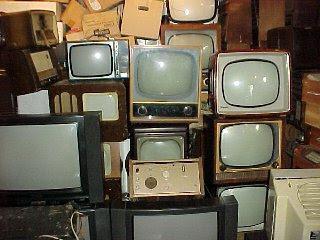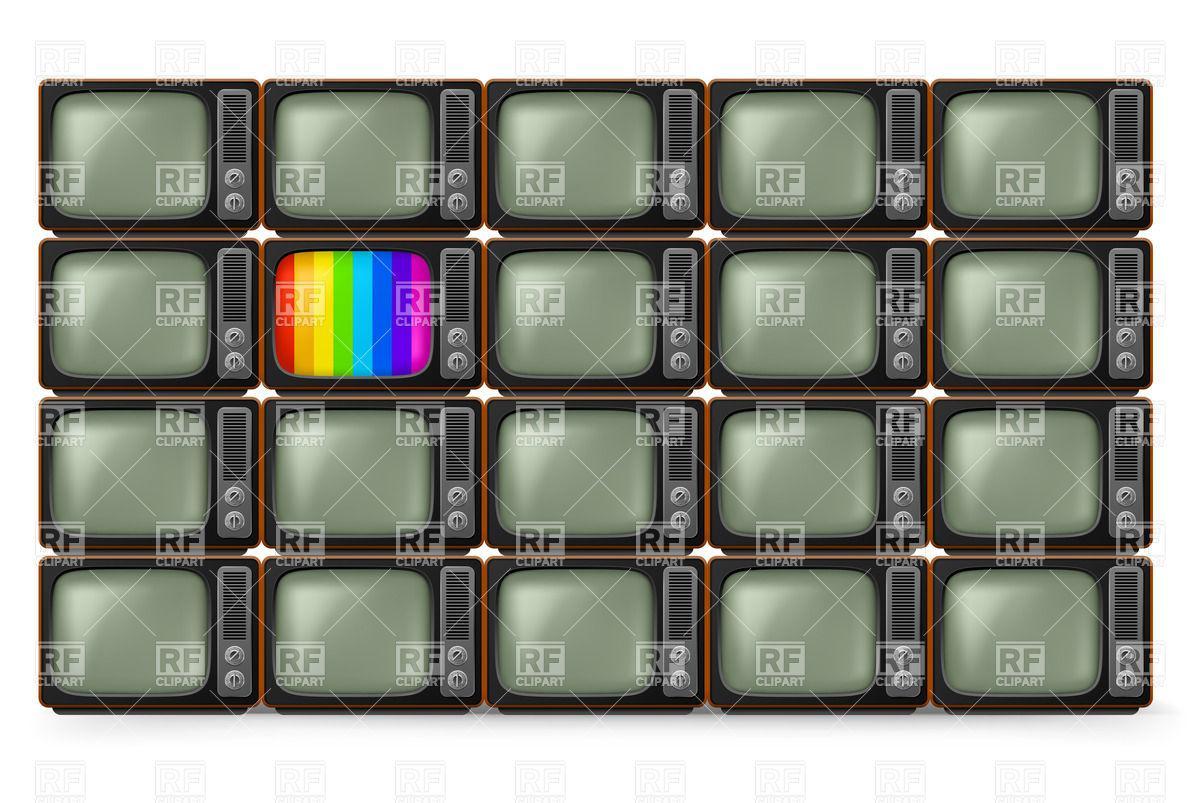The first image is the image on the left, the second image is the image on the right. Considering the images on both sides, is "There is at least one tv with rainbow stripes on the screen" valid? Answer yes or no. Yes. The first image is the image on the left, the second image is the image on the right. Examine the images to the left and right. Is the description "The right image shows four stacked rows of same-model TVs, and at least one TV has a gray screen and at least one TV has a rainbow 'test pattern'." accurate? Answer yes or no. Yes. 